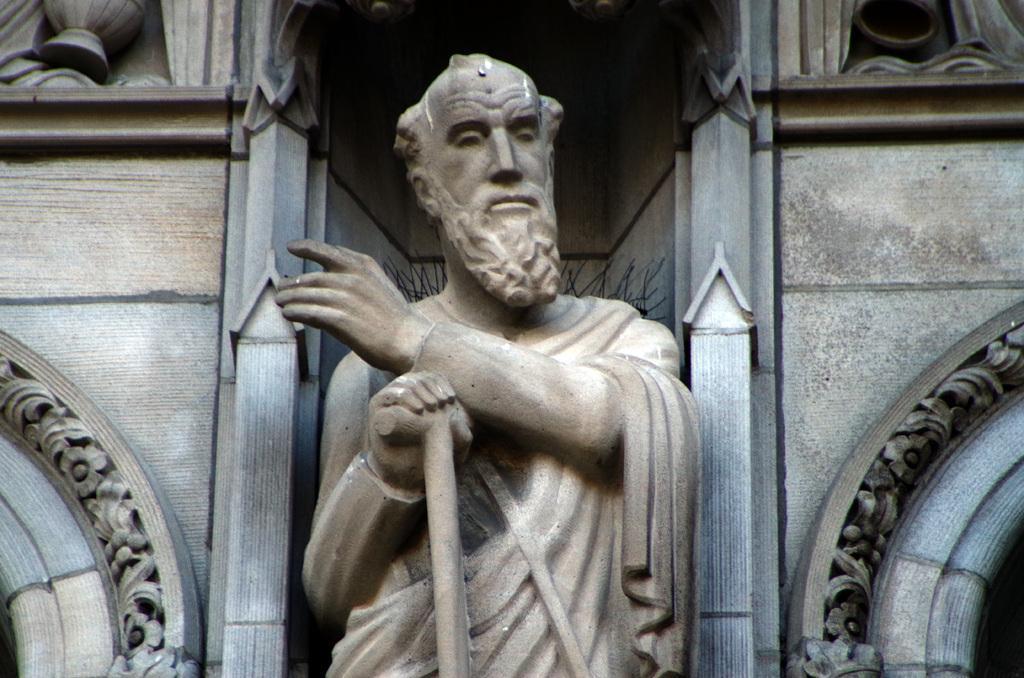Describe this image in one or two sentences. In this image in the center there is a statue and there is wall in the background. On the right side there is a design on the wall. 